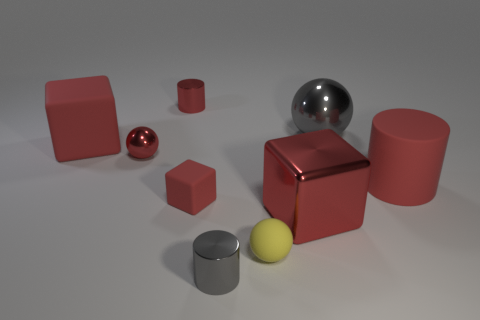Subtract all red cubes. How many were subtracted if there are1red cubes left? 2 Subtract all cubes. How many objects are left? 6 Subtract all large purple matte cubes. Subtract all small red metal balls. How many objects are left? 8 Add 3 large cylinders. How many large cylinders are left? 4 Add 3 gray metallic cylinders. How many gray metallic cylinders exist? 4 Subtract 1 red cylinders. How many objects are left? 8 